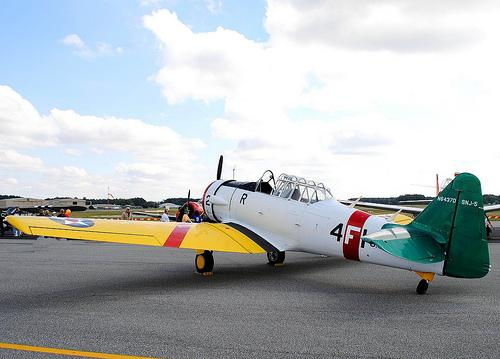What are some important objects or details in this image? Important objects and details include the airplane, its wheels, the wings, the tail, the blue circle with a star inside, the ground, and the cloudy sky. Can you find any text written on the plane? If yes, describe its location. Yes, there are numbers and letters on the plane, located near the center of the plane's body. Describe the mood or emotion conveyed by the image. The image evokes a sense of excitement and anticipation, as the small colorful airplane is surrounded by lively elements such as the cloudy sky, people, and runway markings. Provide a brief description of the scene in the image. A small multi-colored airplane is parked on a runway surrounded by a light blue cloudy sky and several people, with yellow wings, a green tail, and black wheels. What color is the circle on the plane's wing? The circle on the plane's wing is blue. List the colors of different parts of the airplane. The body of the airplane is white, the wings are yellow, the tail is green, and the wheels are black. What does the ground underneath the airplane look like? The ground is grey with a yellow line painted on the tarmac. What can you see inside the blue circle on the plane's wing? Inside the blue circle, there is a white star with a red circle inside it. What does the sky look like in the image? The sky is light blue and mostly cloudy. How many wheels can be seen on the airplane? Three wheels can be seen on the airplane. What color are the clouds in the image? White Is the sun shining brightly over the sky? The sun casts a warm glow on the scene. The provided information mentions a cloudy sky, which implies that the sun is not shining brightly. Adding a statement about the sun would create a contradiction with the existing information. Can you see a team of ground personnel near the runway? They are preparing for the plane's take-off. There is no mention of ground personnel in the provided information. Introducing such a concept would mislead the viewer into searching for non-existent objects in the image. What part of the plane appears to be empty? Cockpit What is the color of the circle on the wing of the plane? Blue Identify the text present on the plane. Numbers and letter Write a caption for this scene in a poetic style. A small, multi-colored plane sits grounded, wings of yellow bright, amidst a sky adorned with white clouds in blue light. Identify the color of the plane's wheel. Black What is the shape inside the blue circle found on the plane's wing? Star Examine the background of the image and identify the colors present. Light blue, white, and grey Describe the color and shape of the ground. Grey and flat Look for a pilot waving from the cockpit window. The pilot is happy to be taking off. No, it's not mentioned in the image. Give a brief description of the scene shown in the image. A small multi-colored airplane is parked on the ground surrounded by cloudy skies and a few tan buildings. Describe in detail the appearance of the plane's tail. The tail of the plane is green with a distinct shape and angle. In this image, is the plane flying or on the ground? On the ground List the colors present on the wing of the airplane. Yellow, blue, red, and white What event can be inferred from this image? Plane parked on a runway Describe the mood of the sky. Mostly cloudy Which elements of the plane are yellow? Wings Is there a banner attached to the plane's tail? It displays a message congratulating the airline's anniversary. There is no mention of a banner or any message in the provided information. By adding this piece of information, the viewer would be confused and search for irrelevant details in the image. Create a brief story about this image involving a group of people. Several people gathered around the small, multi-colored plane on the runway, admiring its vibrant colors and preparing for a journey into the cloudy sky. Interpret the objects seen around the plane's wing. A blue circle with a white star and red circle inside Is there an air traffic control tower in the background? There should be a tall tower visible. The provided information does not mention any air traffic control tower in the image. Introducing such a concept would confuse the viewer as it is not relevant to the image. Can you spot a red bird sitting on the plane's wing? There is a red bird perched there. There is no mention of any bird in the provided information. The presence of a bird would be misleading as it is not relevant to the image. Identify the expression of the people seen in the photo. Cannot determine, no clear facial expressions visible 